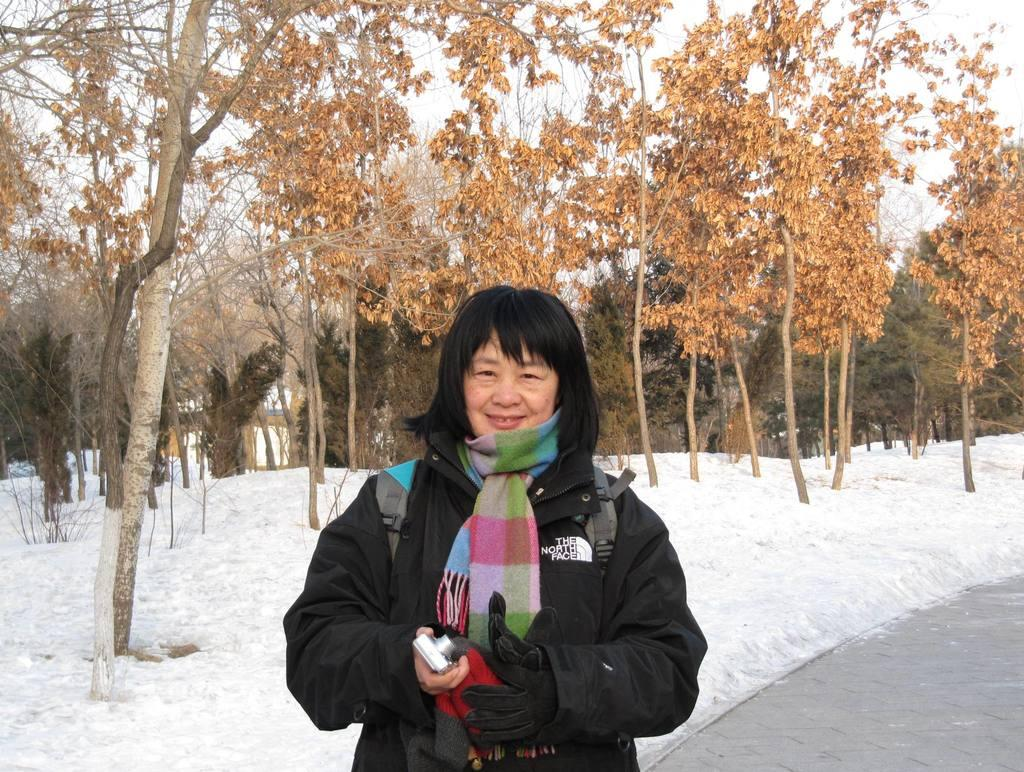Who is the main subject in the foreground of the picture? There is a woman in the foreground of the picture. What can be seen in the middle of the picture? Trees and snow are present in the middle of the picture. What is visible at the top of the picture? The sky is visible at the top of the picture. What is present in the background of the picture? Snow and trees are visible in the background of the picture. Where is the grape drawer located in the image? There is no grape drawer present in the image. What type of porter is assisting the woman in the image? There is no porter present in the image; it only features a woman, trees, snow, and the sky. 